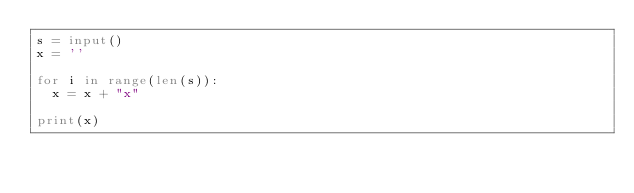Convert code to text. <code><loc_0><loc_0><loc_500><loc_500><_Python_>s = input()
x = ''

for i in range(len(s)):
  x = x + "x"
  
print(x)</code> 